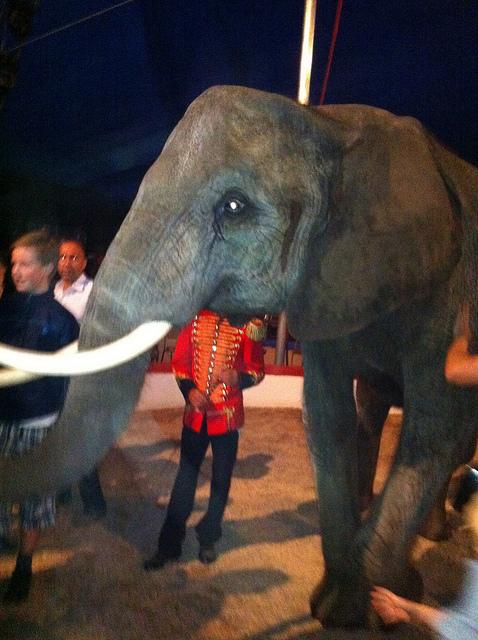What event might this be?

Choices:
A) circus show
B) concert
C) wrestling show
D) award show circus show 